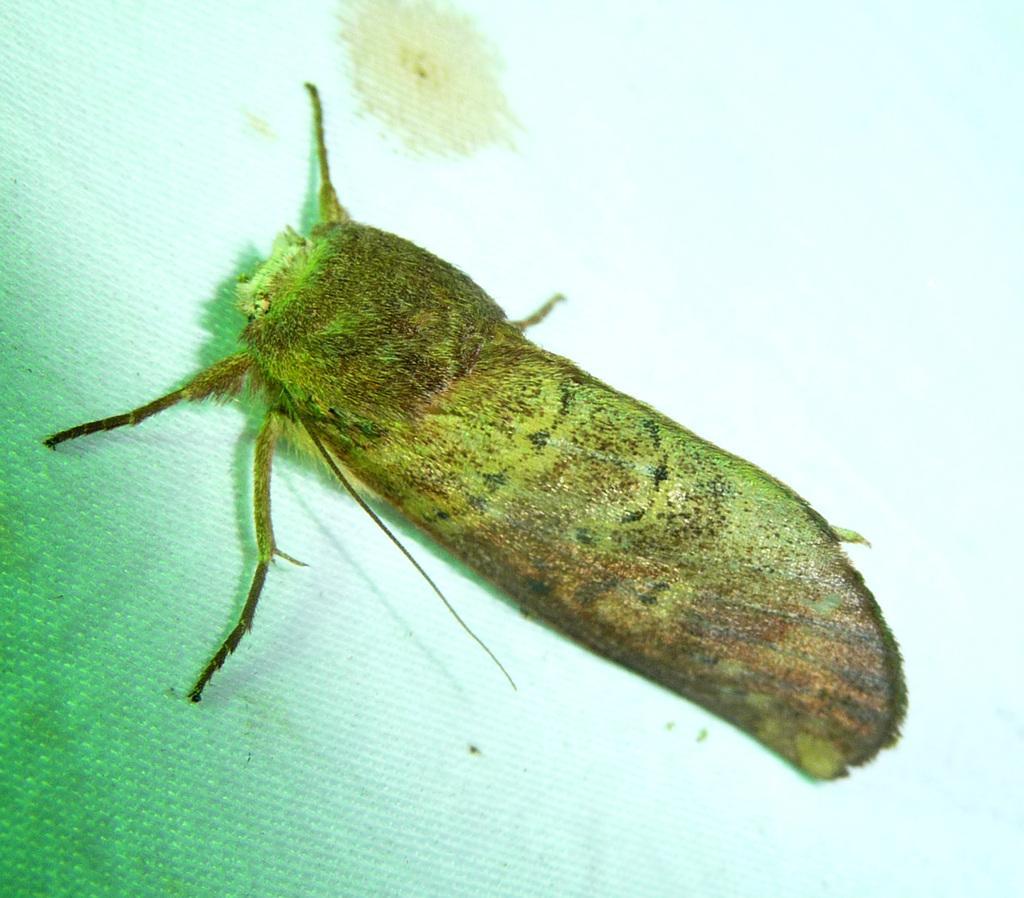Could you give a brief overview of what you see in this image? As we can see in the image there is an insect. 